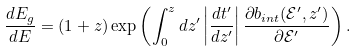<formula> <loc_0><loc_0><loc_500><loc_500>\frac { d E _ { g } } { d E } = ( 1 + z ) \exp \left ( \int _ { 0 } ^ { z } d z ^ { \prime } \left | \frac { d t ^ { \prime } } { d z ^ { \prime } } \right | \frac { \partial b _ { i n t } ( \mathcal { E } ^ { \prime } , z ^ { \prime } ) } { \partial \mathcal { E } ^ { \prime } } \right ) .</formula> 